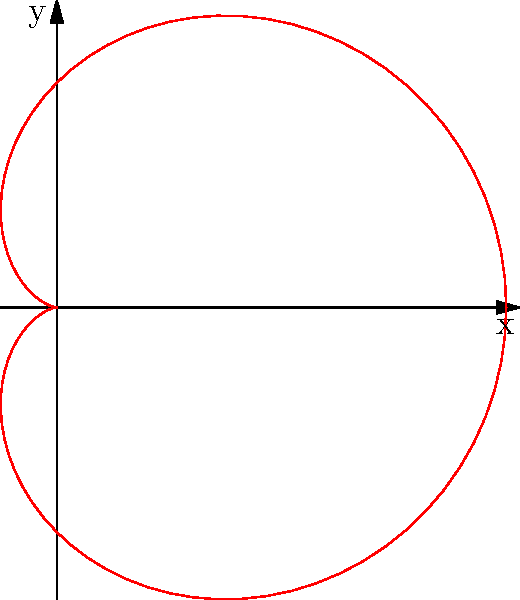In polar coordinates, a cardioid is given by the equation $r = 2(1 + \cos\theta)$. Calculate the area enclosed by this cardioid curve. To find the area enclosed by the cardioid, we'll follow these steps:

1) The general formula for the area enclosed by a polar curve is:

   $$A = \frac{1}{2} \int_0^{2\pi} r^2 d\theta$$

2) Substitute the given equation $r = 2(1 + \cos\theta)$ into the formula:

   $$A = \frac{1}{2} \int_0^{2\pi} [2(1 + \cos\theta)]^2 d\theta$$

3) Expand the squared term:

   $$A = \frac{1}{2} \int_0^{2\pi} 4(1 + 2\cos\theta + \cos^2\theta) d\theta$$

4) Distribute the 4:

   $$A = 2 \int_0^{2\pi} (1 + 2\cos\theta + \cos^2\theta) d\theta$$

5) Integrate each term:
   - $\int_0^{2\pi} 1 d\theta = 2\pi$
   - $\int_0^{2\pi} 2\cos\theta d\theta = 2[\sin\theta]_0^{2\pi} = 0$
   - $\int_0^{2\pi} \cos^2\theta d\theta = \int_0^{2\pi} \frac{1 + \cos2\theta}{2} d\theta = [\frac{\theta}{2} + \frac{\sin2\theta}{4}]_0^{2\pi} = \pi$

6) Sum up the results:

   $$A = 2(2\pi + 0 + \pi) = 6\pi$$

Therefore, the area enclosed by the cardioid is $6\pi$ square units.
Answer: $6\pi$ square units 